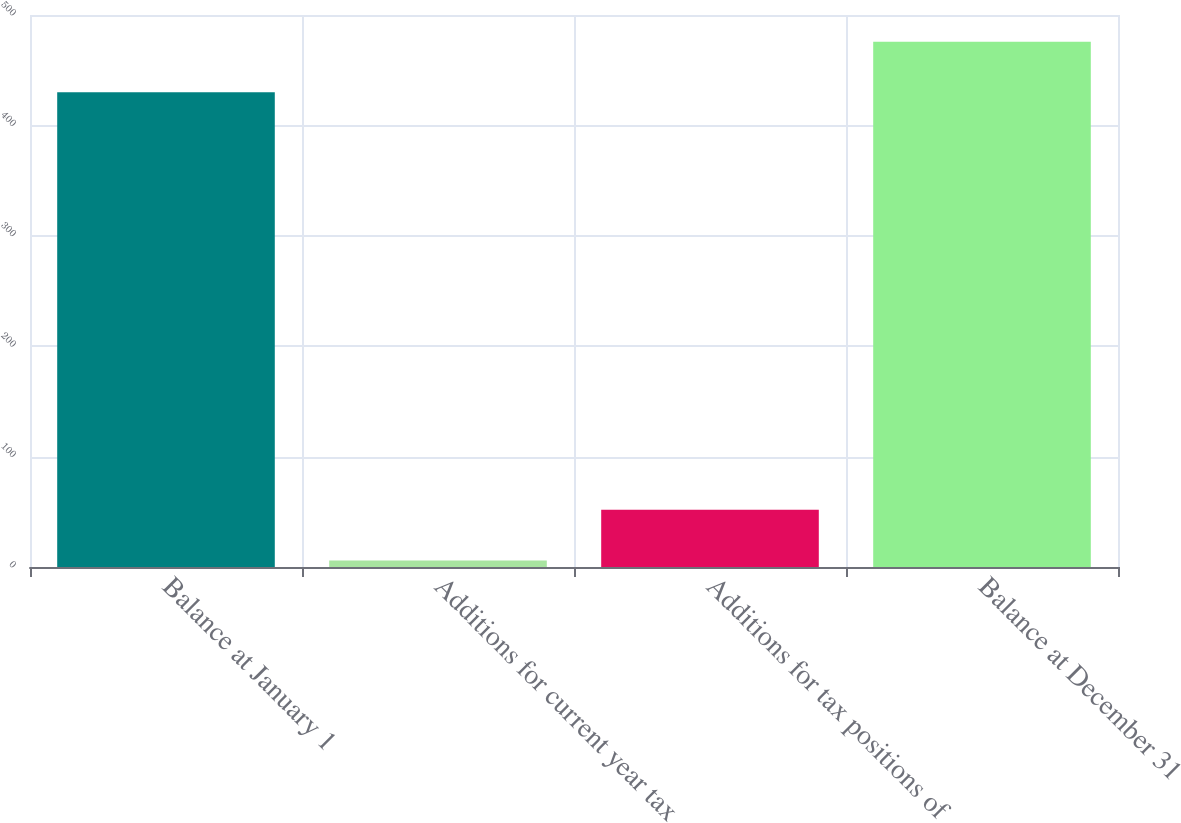Convert chart. <chart><loc_0><loc_0><loc_500><loc_500><bar_chart><fcel>Balance at January 1<fcel>Additions for current year tax<fcel>Additions for tax positions of<fcel>Balance at December 31<nl><fcel>430<fcel>6<fcel>51.8<fcel>475.8<nl></chart> 